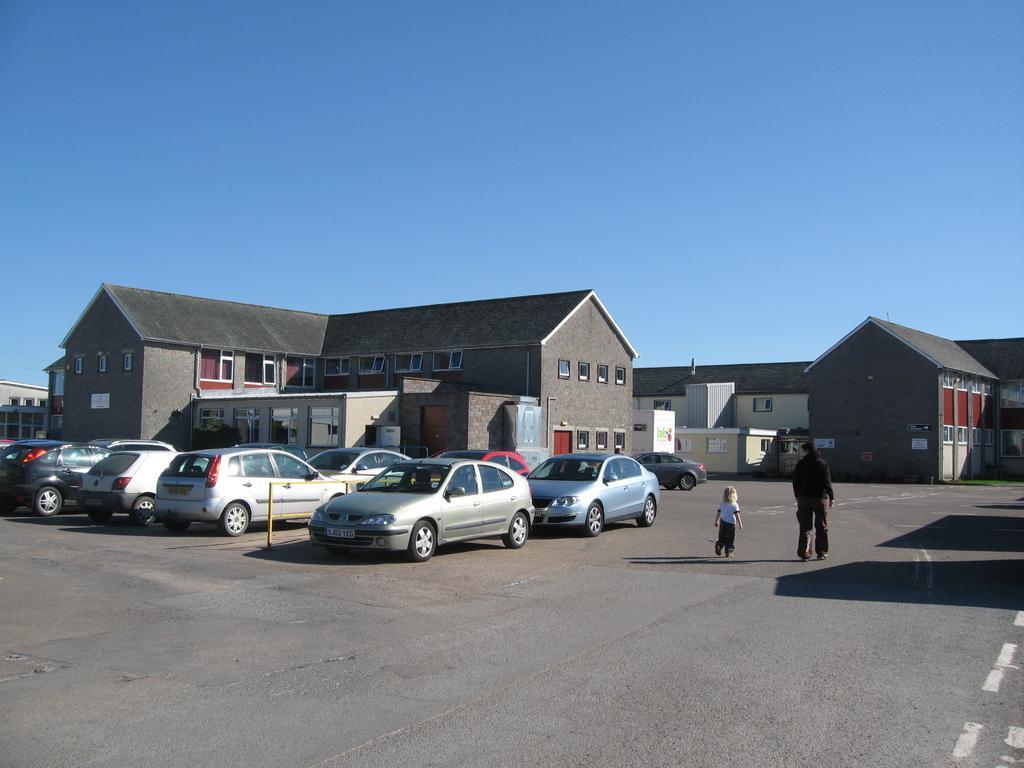Can you describe this image briefly? These are the buildings with the windows and glass doors. I can see the cars, which are parked. This looks like a barricade. I can see a person and a kid walking on the road. This is the sky. 